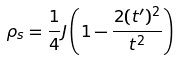Convert formula to latex. <formula><loc_0><loc_0><loc_500><loc_500>\rho _ { s } = \frac { 1 } { 4 } J \left ( 1 - \frac { 2 ( t ^ { \prime } ) ^ { 2 } } { t ^ { 2 } } \right )</formula> 